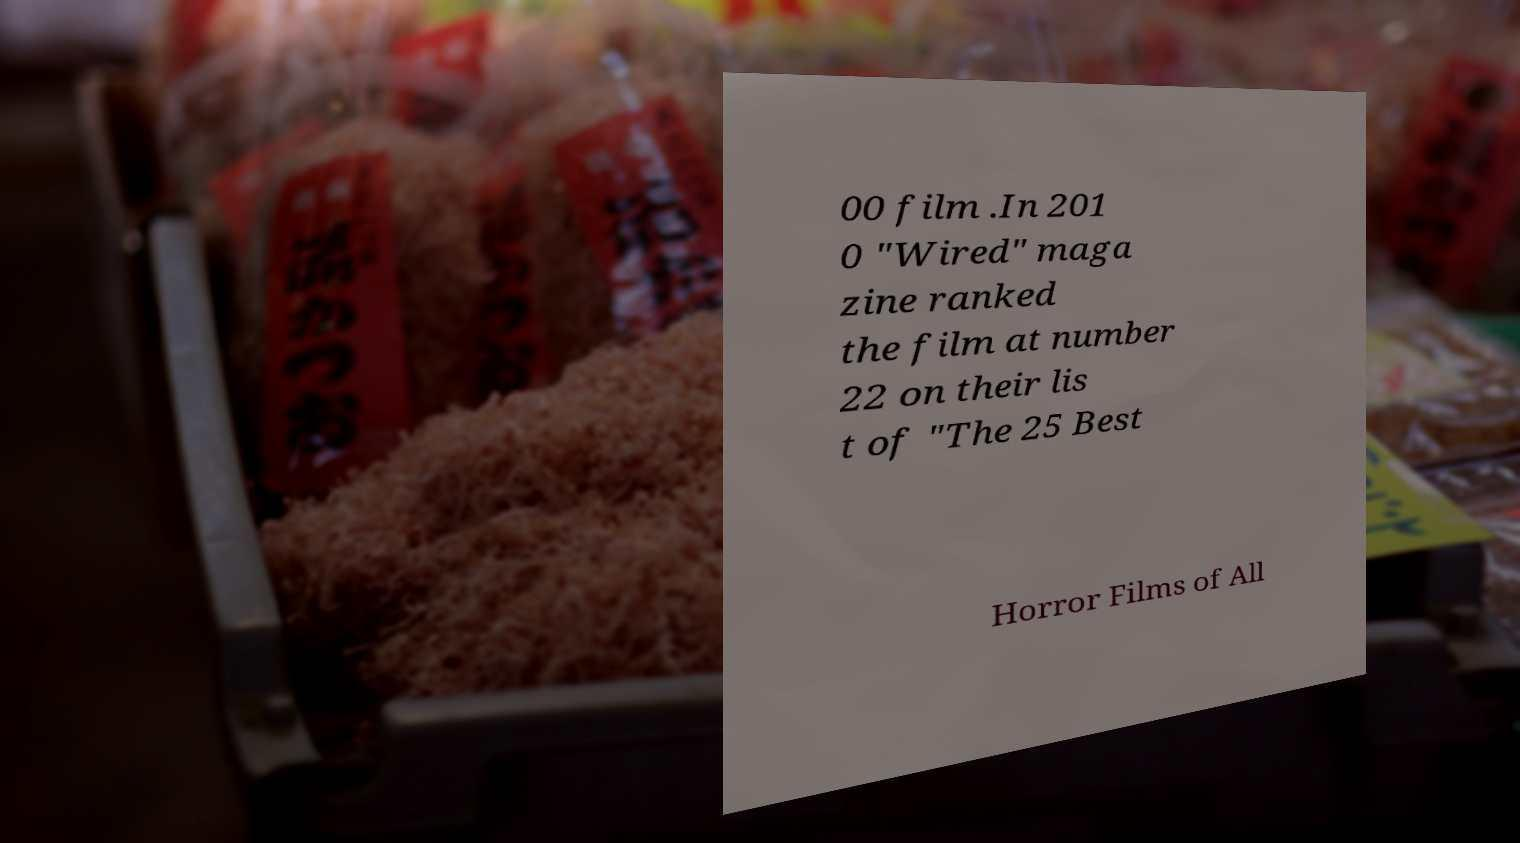Please identify and transcribe the text found in this image. 00 film .In 201 0 "Wired" maga zine ranked the film at number 22 on their lis t of "The 25 Best Horror Films of All 